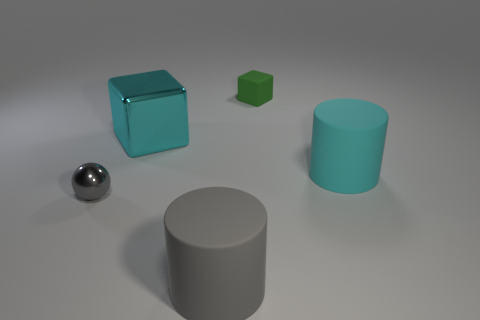Add 3 large rubber objects. How many objects exist? 8 Subtract all cylinders. How many objects are left? 3 Subtract 0 yellow cubes. How many objects are left? 5 Subtract all rubber cylinders. Subtract all cyan metallic cubes. How many objects are left? 2 Add 5 cyan blocks. How many cyan blocks are left? 6 Add 4 metal balls. How many metal balls exist? 5 